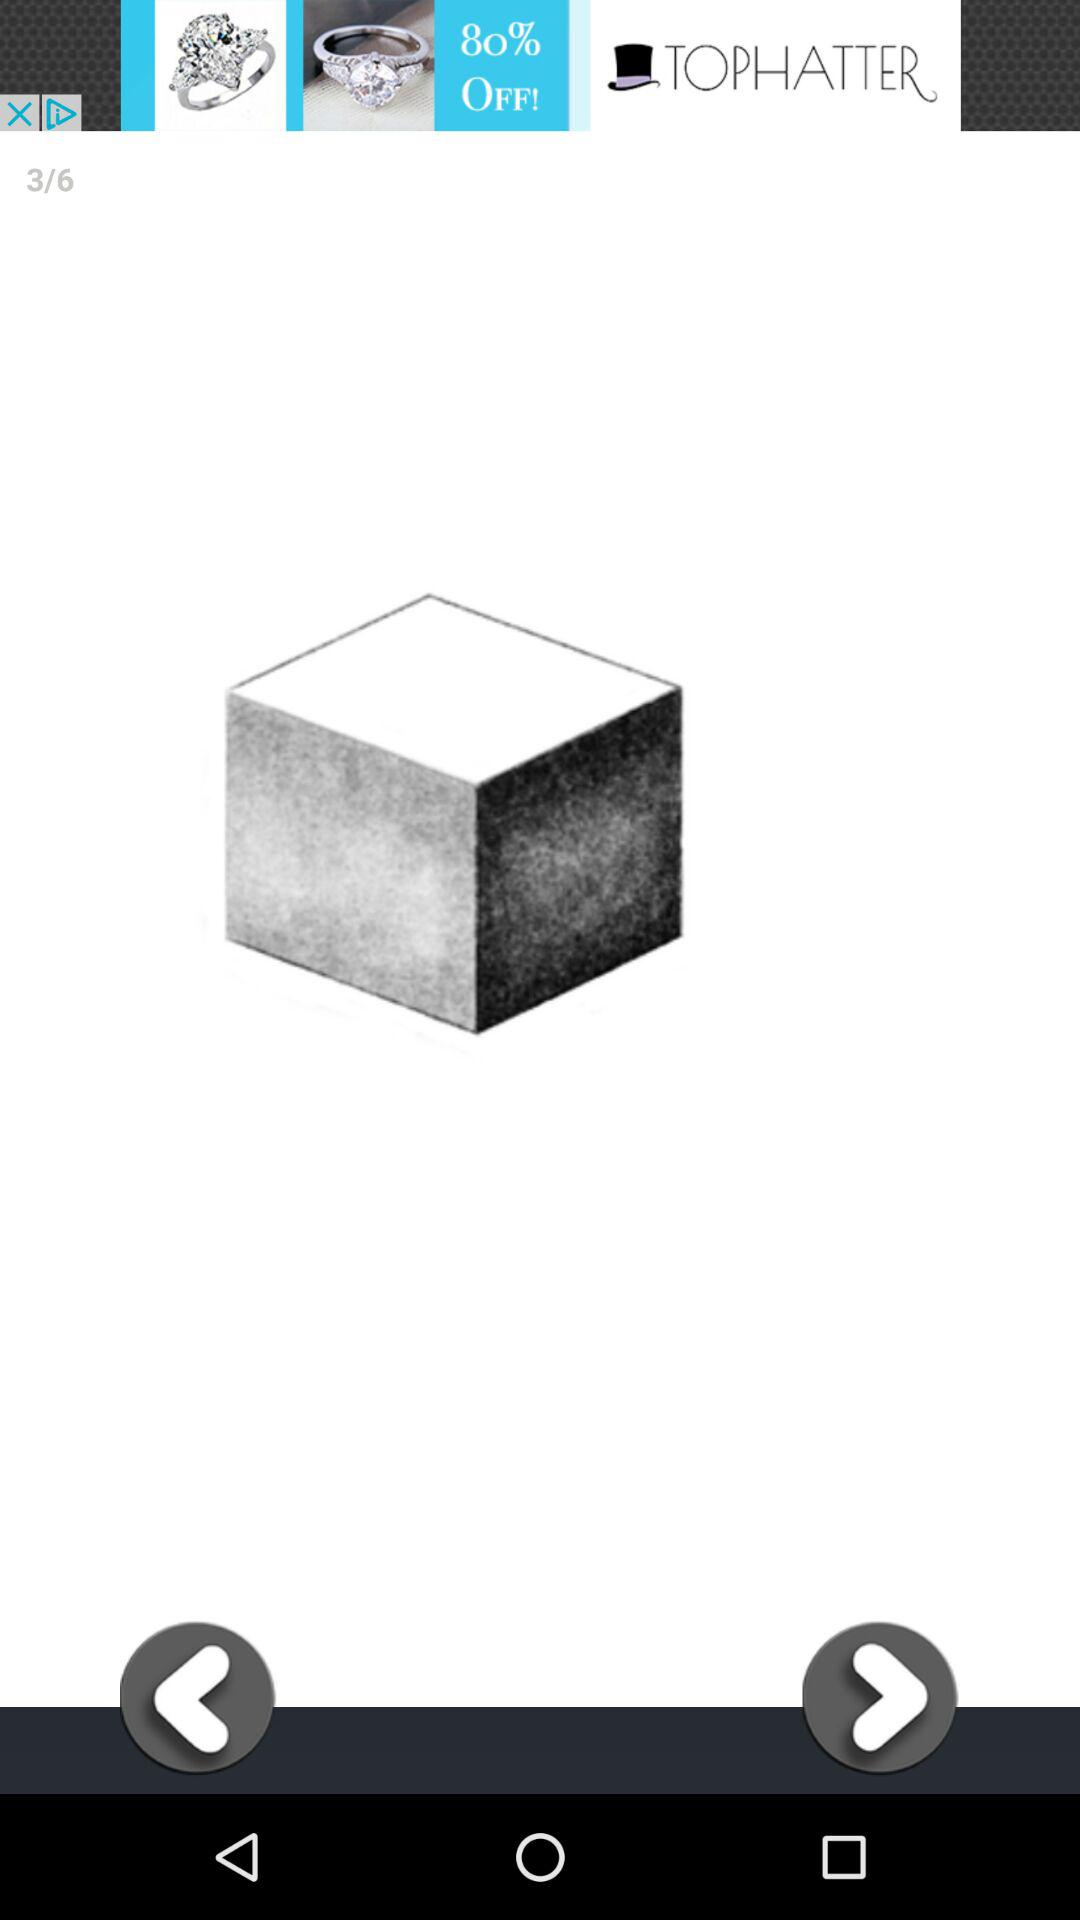On which image am I? You are on the third image. 